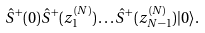<formula> <loc_0><loc_0><loc_500><loc_500>\hat { S } ^ { + } ( 0 ) \hat { S } ^ { + } ( z ^ { ( N ) } _ { 1 } ) \dots \hat { S } ^ { + } ( z ^ { ( N ) } _ { N - 1 } ) | 0 \rangle .</formula> 